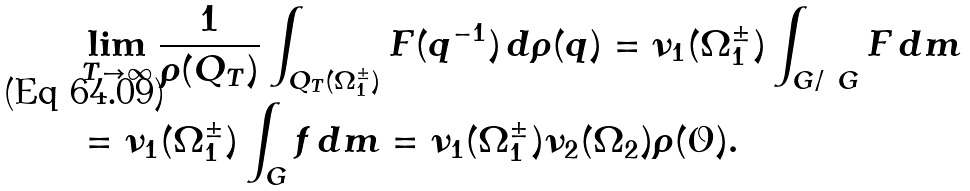Convert formula to latex. <formula><loc_0><loc_0><loc_500><loc_500>& \lim _ { T \to \infty } \frac { 1 } { \rho ( Q _ { T } ) } \int _ { Q _ { T } ( \Omega _ { 1 } ^ { \pm } ) } F ( q ^ { - 1 } ) \, d \rho ( q ) = \nu _ { 1 } ( \Omega _ { 1 } ^ { \pm } ) \int _ { G / \ G } F \, d m \\ & = \nu _ { 1 } ( \Omega _ { 1 } ^ { \pm } ) \int _ { G } f \, d m = \nu _ { 1 } ( \Omega _ { 1 } ^ { \pm } ) \nu _ { 2 } ( \Omega _ { 2 } ) \rho ( \mathcal { O } ) .</formula> 